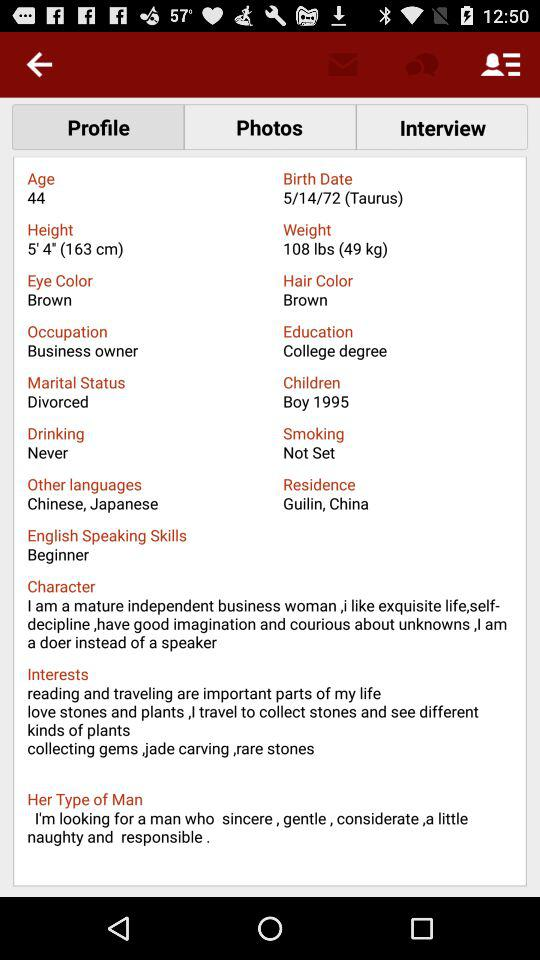What is the mentioned age? The mentioned age is 44. 